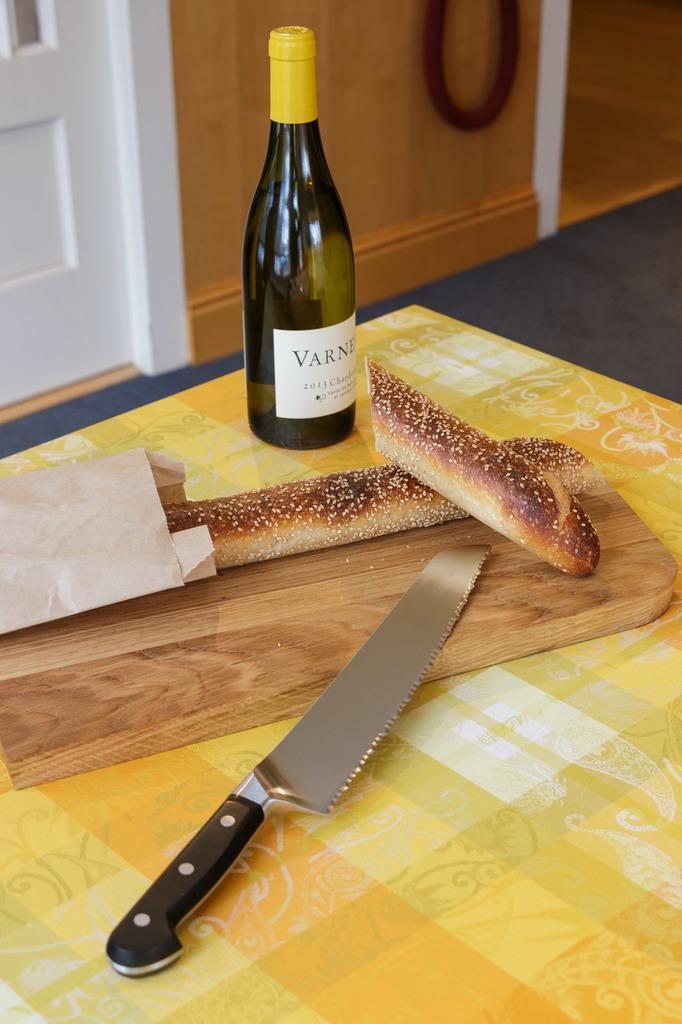How would you summarize this image in a sentence or two? In the center we can see table,on table there is a knife,bread,paper and bottle. In the background there is a wood wall and door. 